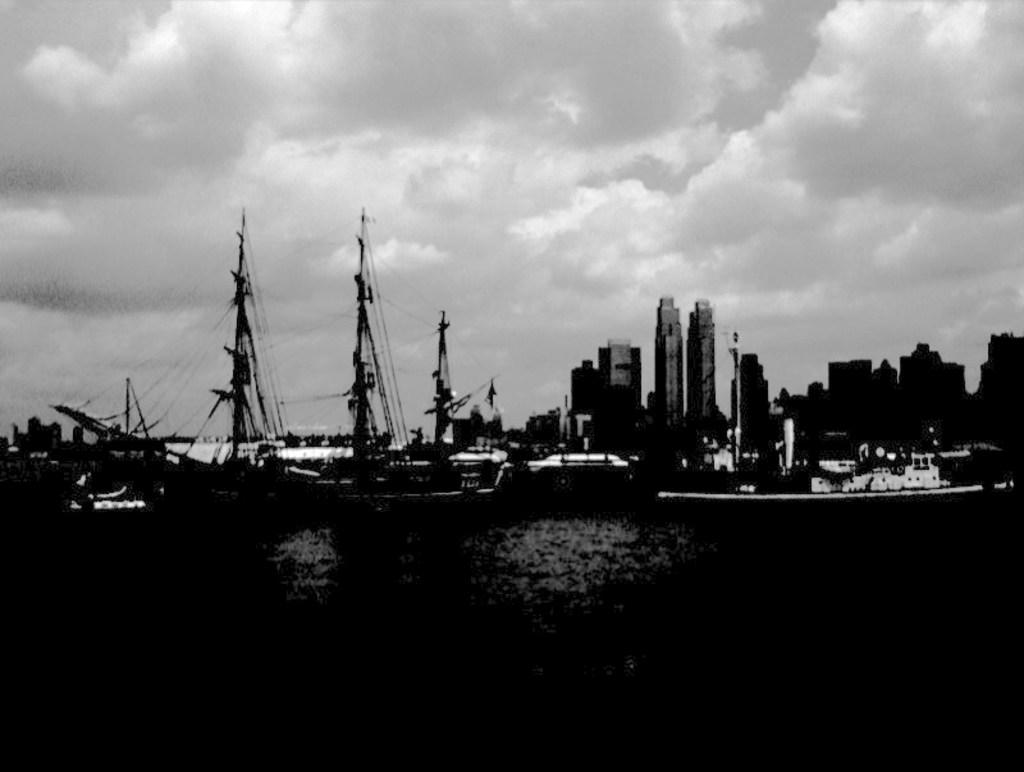What is the color scheme of the image? The image is black and white. What can be seen in the water in the image? There are many boats in the image. What features are present on each boat? Each boat has poles and ropes. What type of structures can be seen in the image? There are many buildings in the image. What is visible at the top of the image? The sky is visible at the top of the image. What can be observed in the sky? There are clouds in the sky. Can you tell me how many houses are visible in the image? There is no mention of houses in the image; it features many boats, buildings, and a sky with clouds. What type of camp can be seen in the image? There is no camp present in the image. 